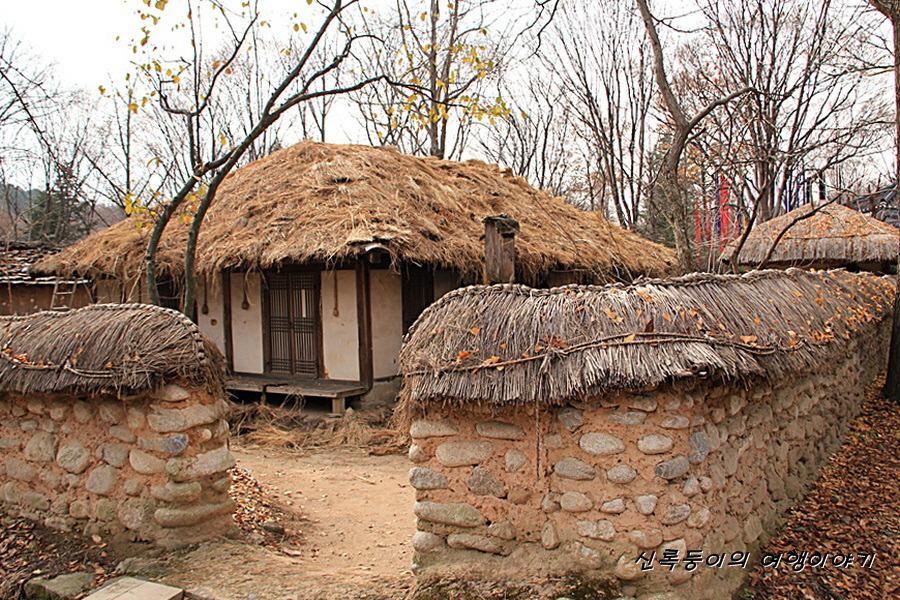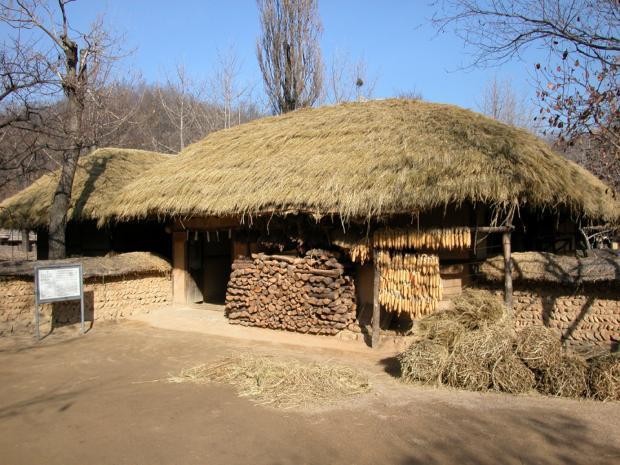The first image is the image on the left, the second image is the image on the right. Examine the images to the left and right. Is the description "The left image shows a rock wall around at least one squarish building with smooth beige walls and a slightly peaked thatched roof." accurate? Answer yes or no. Yes. The first image is the image on the left, the second image is the image on the right. Analyze the images presented: Is the assertion "In at least one image there is a hut with a roof made out of black straw." valid? Answer yes or no. No. 